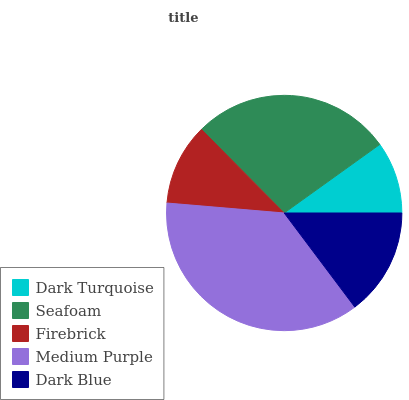Is Dark Turquoise the minimum?
Answer yes or no. Yes. Is Medium Purple the maximum?
Answer yes or no. Yes. Is Seafoam the minimum?
Answer yes or no. No. Is Seafoam the maximum?
Answer yes or no. No. Is Seafoam greater than Dark Turquoise?
Answer yes or no. Yes. Is Dark Turquoise less than Seafoam?
Answer yes or no. Yes. Is Dark Turquoise greater than Seafoam?
Answer yes or no. No. Is Seafoam less than Dark Turquoise?
Answer yes or no. No. Is Dark Blue the high median?
Answer yes or no. Yes. Is Dark Blue the low median?
Answer yes or no. Yes. Is Seafoam the high median?
Answer yes or no. No. Is Dark Turquoise the low median?
Answer yes or no. No. 